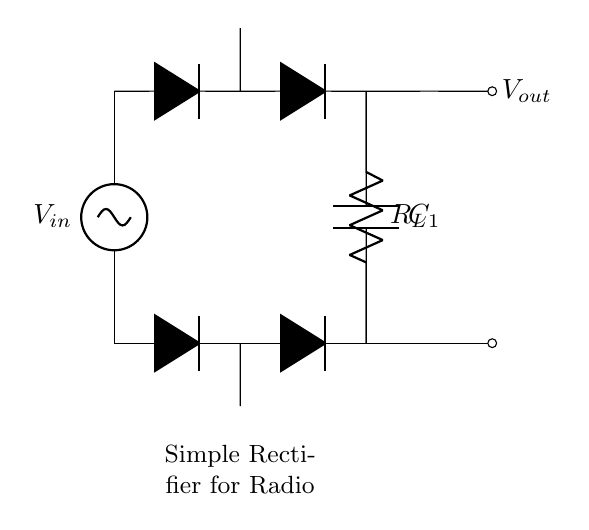What type of rectifier is shown in the circuit? The circuit diagram depicts a bridge rectifier, which is identified by the configuration of four diodes arranged in a bridge format, allowing AC input to be converted into DC output.
Answer: bridge rectifier How many diodes are used in the circuit? The circuit diagram contains four diodes, indicated by the four diode symbols that are interconnected to form the bridge rectifier configuration.
Answer: four What is the purpose of capacitor C1 in the circuit? The capacitor C1 is used to smooth the output voltage by filtering the rectified signal, which reduces fluctuations and voltage ripples after the AC has been converted to DC.
Answer: smooth What is the output voltage represented as in the circuit? The output voltage is indicated at the terminal labeled Vout, located on the right side of the circuit, where the rectified voltage is accessed.
Answer: Vout What happens to the current direction after rectification? After passing through the rectifier, the current direction is converted to a unidirectional flow, meaning it only flows in one direction toward the load resistor, instead of alternating as in the AC source.
Answer: unidirectional What is the function of load resistor R_L? The load resistor R_L converts the electrical energy from the circuit output into useful work or heat, representing the device that uses the rectified DC power.
Answer: convert energy Why is this circuit suitable for a homemade radio receiver? This circuit is suitable because it efficiently converts AC signals from radio waves into a stable DC voltage, which powers the radio components and ensures consistent operation.
Answer: efficient conversion 